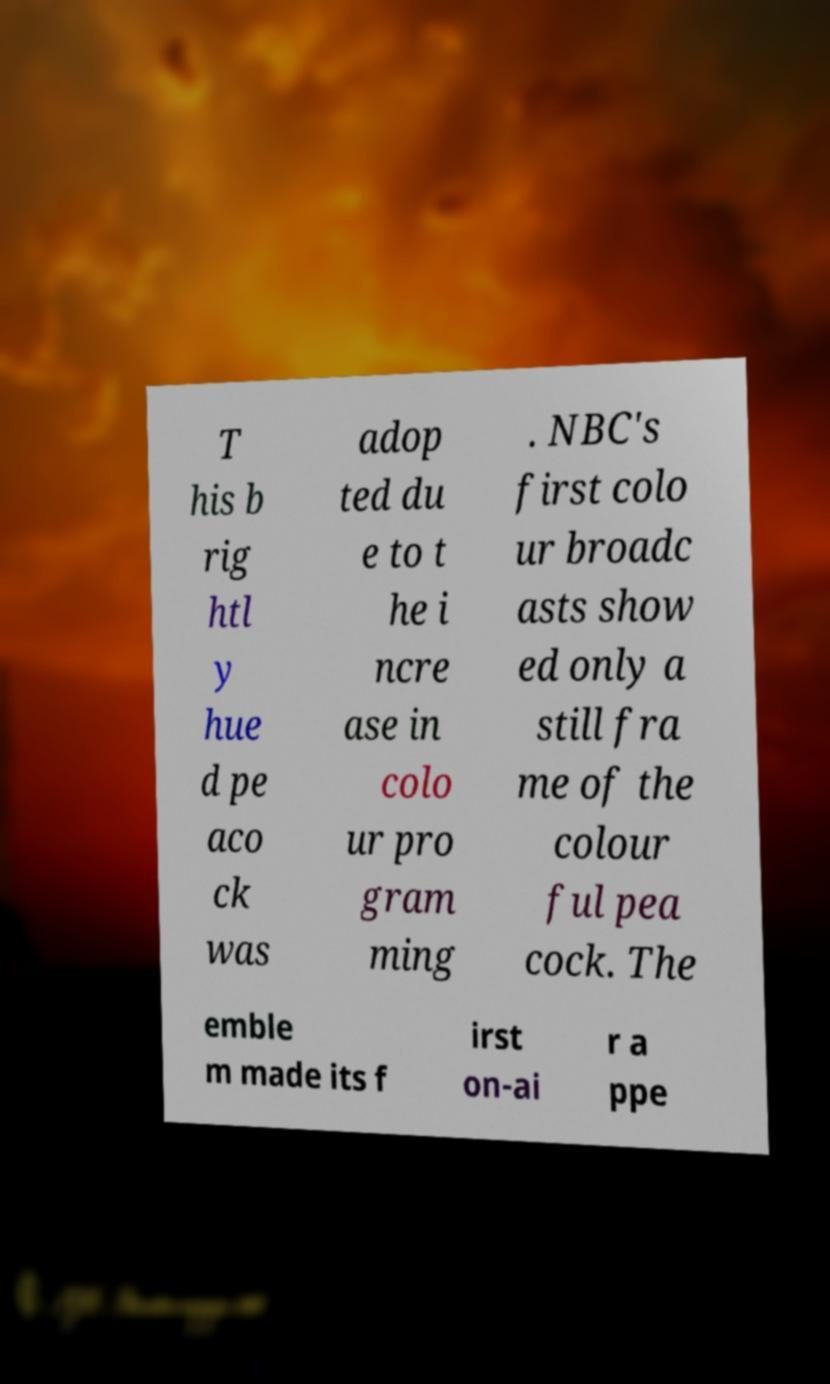Could you assist in decoding the text presented in this image and type it out clearly? T his b rig htl y hue d pe aco ck was adop ted du e to t he i ncre ase in colo ur pro gram ming . NBC's first colo ur broadc asts show ed only a still fra me of the colour ful pea cock. The emble m made its f irst on-ai r a ppe 